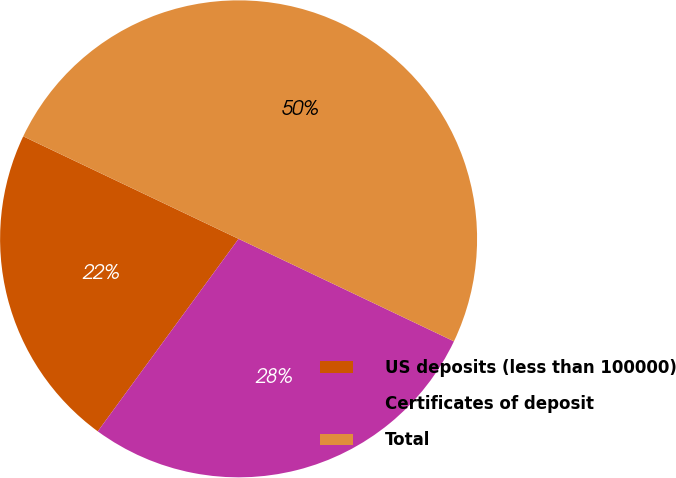<chart> <loc_0><loc_0><loc_500><loc_500><pie_chart><fcel>US deposits (less than 100000)<fcel>Certificates of deposit<fcel>Total<nl><fcel>22.02%<fcel>27.98%<fcel>50.0%<nl></chart> 